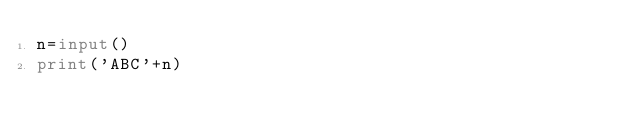<code> <loc_0><loc_0><loc_500><loc_500><_Python_>n=input()
print('ABC'+n)</code> 